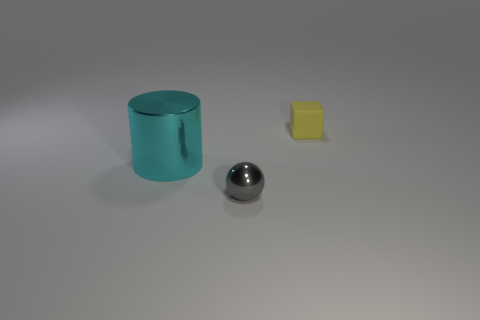Add 3 large red cylinders. How many objects exist? 6 Subtract all balls. How many objects are left? 2 Add 2 small yellow blocks. How many small yellow blocks exist? 3 Subtract 0 purple cubes. How many objects are left? 3 Subtract all purple rubber blocks. Subtract all tiny balls. How many objects are left? 2 Add 3 matte objects. How many matte objects are left? 4 